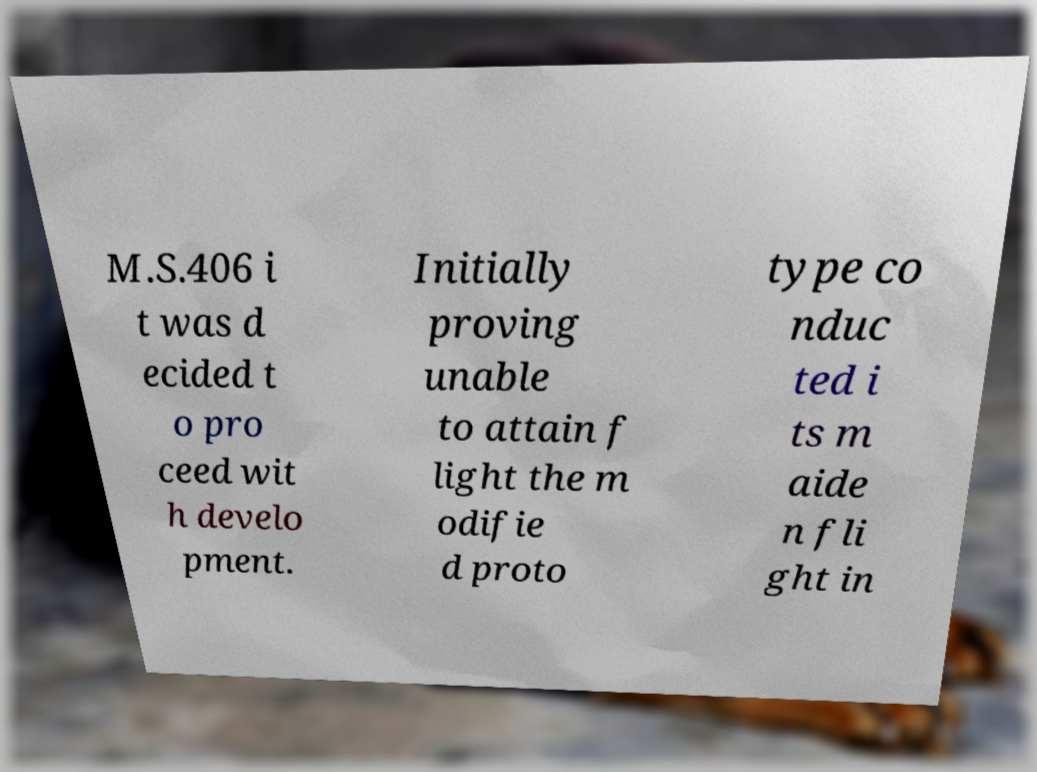Can you accurately transcribe the text from the provided image for me? M.S.406 i t was d ecided t o pro ceed wit h develo pment. Initially proving unable to attain f light the m odifie d proto type co nduc ted i ts m aide n fli ght in 